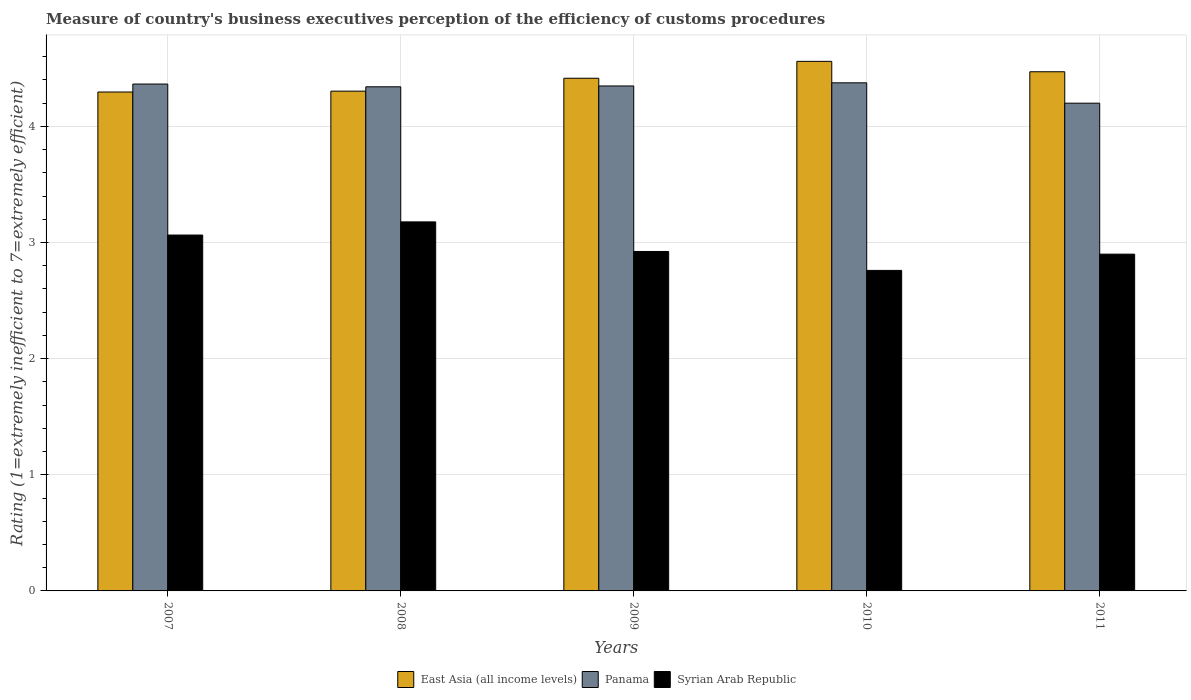Are the number of bars per tick equal to the number of legend labels?
Your answer should be compact. Yes. How many bars are there on the 3rd tick from the left?
Your answer should be very brief. 3. What is the label of the 1st group of bars from the left?
Offer a very short reply. 2007. What is the rating of the efficiency of customs procedure in Panama in 2007?
Your answer should be compact. 4.36. Across all years, what is the maximum rating of the efficiency of customs procedure in Panama?
Provide a short and direct response. 4.38. In which year was the rating of the efficiency of customs procedure in Panama maximum?
Provide a succinct answer. 2010. In which year was the rating of the efficiency of customs procedure in Panama minimum?
Offer a very short reply. 2011. What is the total rating of the efficiency of customs procedure in East Asia (all income levels) in the graph?
Ensure brevity in your answer.  22.05. What is the difference between the rating of the efficiency of customs procedure in Panama in 2007 and that in 2011?
Ensure brevity in your answer.  0.16. What is the difference between the rating of the efficiency of customs procedure in Syrian Arab Republic in 2008 and the rating of the efficiency of customs procedure in East Asia (all income levels) in 2010?
Make the answer very short. -1.38. What is the average rating of the efficiency of customs procedure in Panama per year?
Offer a terse response. 4.33. In the year 2007, what is the difference between the rating of the efficiency of customs procedure in Syrian Arab Republic and rating of the efficiency of customs procedure in Panama?
Keep it short and to the point. -1.3. What is the ratio of the rating of the efficiency of customs procedure in East Asia (all income levels) in 2009 to that in 2011?
Keep it short and to the point. 0.99. Is the difference between the rating of the efficiency of customs procedure in Syrian Arab Republic in 2009 and 2011 greater than the difference between the rating of the efficiency of customs procedure in Panama in 2009 and 2011?
Ensure brevity in your answer.  No. What is the difference between the highest and the second highest rating of the efficiency of customs procedure in Panama?
Make the answer very short. 0.01. What is the difference between the highest and the lowest rating of the efficiency of customs procedure in East Asia (all income levels)?
Provide a succinct answer. 0.26. What does the 2nd bar from the left in 2009 represents?
Keep it short and to the point. Panama. What does the 3rd bar from the right in 2010 represents?
Offer a very short reply. East Asia (all income levels). How many years are there in the graph?
Provide a succinct answer. 5. Are the values on the major ticks of Y-axis written in scientific E-notation?
Provide a succinct answer. No. Does the graph contain any zero values?
Ensure brevity in your answer.  No. What is the title of the graph?
Your answer should be very brief. Measure of country's business executives perception of the efficiency of customs procedures. What is the label or title of the Y-axis?
Keep it short and to the point. Rating (1=extremely inefficient to 7=extremely efficient). What is the Rating (1=extremely inefficient to 7=extremely efficient) in East Asia (all income levels) in 2007?
Your answer should be very brief. 4.3. What is the Rating (1=extremely inefficient to 7=extremely efficient) in Panama in 2007?
Provide a short and direct response. 4.36. What is the Rating (1=extremely inefficient to 7=extremely efficient) in Syrian Arab Republic in 2007?
Your answer should be very brief. 3.06. What is the Rating (1=extremely inefficient to 7=extremely efficient) in East Asia (all income levels) in 2008?
Your answer should be very brief. 4.3. What is the Rating (1=extremely inefficient to 7=extremely efficient) of Panama in 2008?
Your response must be concise. 4.34. What is the Rating (1=extremely inefficient to 7=extremely efficient) in Syrian Arab Republic in 2008?
Make the answer very short. 3.18. What is the Rating (1=extremely inefficient to 7=extremely efficient) of East Asia (all income levels) in 2009?
Offer a terse response. 4.41. What is the Rating (1=extremely inefficient to 7=extremely efficient) in Panama in 2009?
Provide a succinct answer. 4.35. What is the Rating (1=extremely inefficient to 7=extremely efficient) in Syrian Arab Republic in 2009?
Give a very brief answer. 2.92. What is the Rating (1=extremely inefficient to 7=extremely efficient) in East Asia (all income levels) in 2010?
Offer a terse response. 4.56. What is the Rating (1=extremely inefficient to 7=extremely efficient) in Panama in 2010?
Make the answer very short. 4.38. What is the Rating (1=extremely inefficient to 7=extremely efficient) of Syrian Arab Republic in 2010?
Make the answer very short. 2.76. What is the Rating (1=extremely inefficient to 7=extremely efficient) in East Asia (all income levels) in 2011?
Give a very brief answer. 4.47. What is the Rating (1=extremely inefficient to 7=extremely efficient) in Panama in 2011?
Provide a succinct answer. 4.2. What is the Rating (1=extremely inefficient to 7=extremely efficient) of Syrian Arab Republic in 2011?
Offer a very short reply. 2.9. Across all years, what is the maximum Rating (1=extremely inefficient to 7=extremely efficient) in East Asia (all income levels)?
Provide a succinct answer. 4.56. Across all years, what is the maximum Rating (1=extremely inefficient to 7=extremely efficient) in Panama?
Keep it short and to the point. 4.38. Across all years, what is the maximum Rating (1=extremely inefficient to 7=extremely efficient) in Syrian Arab Republic?
Offer a terse response. 3.18. Across all years, what is the minimum Rating (1=extremely inefficient to 7=extremely efficient) in East Asia (all income levels)?
Provide a short and direct response. 4.3. Across all years, what is the minimum Rating (1=extremely inefficient to 7=extremely efficient) of Syrian Arab Republic?
Keep it short and to the point. 2.76. What is the total Rating (1=extremely inefficient to 7=extremely efficient) in East Asia (all income levels) in the graph?
Provide a succinct answer. 22.05. What is the total Rating (1=extremely inefficient to 7=extremely efficient) in Panama in the graph?
Your answer should be very brief. 21.63. What is the total Rating (1=extremely inefficient to 7=extremely efficient) in Syrian Arab Republic in the graph?
Keep it short and to the point. 14.83. What is the difference between the Rating (1=extremely inefficient to 7=extremely efficient) of East Asia (all income levels) in 2007 and that in 2008?
Provide a short and direct response. -0.01. What is the difference between the Rating (1=extremely inefficient to 7=extremely efficient) in Panama in 2007 and that in 2008?
Make the answer very short. 0.02. What is the difference between the Rating (1=extremely inefficient to 7=extremely efficient) of Syrian Arab Republic in 2007 and that in 2008?
Offer a very short reply. -0.11. What is the difference between the Rating (1=extremely inefficient to 7=extremely efficient) of East Asia (all income levels) in 2007 and that in 2009?
Offer a terse response. -0.12. What is the difference between the Rating (1=extremely inefficient to 7=extremely efficient) in Panama in 2007 and that in 2009?
Make the answer very short. 0.02. What is the difference between the Rating (1=extremely inefficient to 7=extremely efficient) of Syrian Arab Republic in 2007 and that in 2009?
Make the answer very short. 0.14. What is the difference between the Rating (1=extremely inefficient to 7=extremely efficient) of East Asia (all income levels) in 2007 and that in 2010?
Provide a succinct answer. -0.26. What is the difference between the Rating (1=extremely inefficient to 7=extremely efficient) in Panama in 2007 and that in 2010?
Your answer should be compact. -0.01. What is the difference between the Rating (1=extremely inefficient to 7=extremely efficient) of Syrian Arab Republic in 2007 and that in 2010?
Your answer should be compact. 0.3. What is the difference between the Rating (1=extremely inefficient to 7=extremely efficient) of East Asia (all income levels) in 2007 and that in 2011?
Your answer should be compact. -0.17. What is the difference between the Rating (1=extremely inefficient to 7=extremely efficient) in Panama in 2007 and that in 2011?
Keep it short and to the point. 0.16. What is the difference between the Rating (1=extremely inefficient to 7=extremely efficient) of Syrian Arab Republic in 2007 and that in 2011?
Ensure brevity in your answer.  0.16. What is the difference between the Rating (1=extremely inefficient to 7=extremely efficient) of East Asia (all income levels) in 2008 and that in 2009?
Provide a succinct answer. -0.11. What is the difference between the Rating (1=extremely inefficient to 7=extremely efficient) in Panama in 2008 and that in 2009?
Keep it short and to the point. -0.01. What is the difference between the Rating (1=extremely inefficient to 7=extremely efficient) of Syrian Arab Republic in 2008 and that in 2009?
Offer a terse response. 0.25. What is the difference between the Rating (1=extremely inefficient to 7=extremely efficient) of East Asia (all income levels) in 2008 and that in 2010?
Offer a very short reply. -0.26. What is the difference between the Rating (1=extremely inefficient to 7=extremely efficient) in Panama in 2008 and that in 2010?
Keep it short and to the point. -0.03. What is the difference between the Rating (1=extremely inefficient to 7=extremely efficient) of Syrian Arab Republic in 2008 and that in 2010?
Your response must be concise. 0.42. What is the difference between the Rating (1=extremely inefficient to 7=extremely efficient) of East Asia (all income levels) in 2008 and that in 2011?
Provide a short and direct response. -0.17. What is the difference between the Rating (1=extremely inefficient to 7=extremely efficient) in Panama in 2008 and that in 2011?
Keep it short and to the point. 0.14. What is the difference between the Rating (1=extremely inefficient to 7=extremely efficient) in Syrian Arab Republic in 2008 and that in 2011?
Offer a very short reply. 0.28. What is the difference between the Rating (1=extremely inefficient to 7=extremely efficient) in East Asia (all income levels) in 2009 and that in 2010?
Keep it short and to the point. -0.15. What is the difference between the Rating (1=extremely inefficient to 7=extremely efficient) in Panama in 2009 and that in 2010?
Ensure brevity in your answer.  -0.03. What is the difference between the Rating (1=extremely inefficient to 7=extremely efficient) of Syrian Arab Republic in 2009 and that in 2010?
Offer a terse response. 0.16. What is the difference between the Rating (1=extremely inefficient to 7=extremely efficient) of East Asia (all income levels) in 2009 and that in 2011?
Make the answer very short. -0.06. What is the difference between the Rating (1=extremely inefficient to 7=extremely efficient) of Panama in 2009 and that in 2011?
Your response must be concise. 0.15. What is the difference between the Rating (1=extremely inefficient to 7=extremely efficient) in Syrian Arab Republic in 2009 and that in 2011?
Keep it short and to the point. 0.02. What is the difference between the Rating (1=extremely inefficient to 7=extremely efficient) of East Asia (all income levels) in 2010 and that in 2011?
Offer a terse response. 0.09. What is the difference between the Rating (1=extremely inefficient to 7=extremely efficient) in Panama in 2010 and that in 2011?
Offer a very short reply. 0.18. What is the difference between the Rating (1=extremely inefficient to 7=extremely efficient) of Syrian Arab Republic in 2010 and that in 2011?
Keep it short and to the point. -0.14. What is the difference between the Rating (1=extremely inefficient to 7=extremely efficient) of East Asia (all income levels) in 2007 and the Rating (1=extremely inefficient to 7=extremely efficient) of Panama in 2008?
Offer a terse response. -0.04. What is the difference between the Rating (1=extremely inefficient to 7=extremely efficient) of East Asia (all income levels) in 2007 and the Rating (1=extremely inefficient to 7=extremely efficient) of Syrian Arab Republic in 2008?
Keep it short and to the point. 1.12. What is the difference between the Rating (1=extremely inefficient to 7=extremely efficient) of Panama in 2007 and the Rating (1=extremely inefficient to 7=extremely efficient) of Syrian Arab Republic in 2008?
Your answer should be compact. 1.19. What is the difference between the Rating (1=extremely inefficient to 7=extremely efficient) of East Asia (all income levels) in 2007 and the Rating (1=extremely inefficient to 7=extremely efficient) of Panama in 2009?
Keep it short and to the point. -0.05. What is the difference between the Rating (1=extremely inefficient to 7=extremely efficient) in East Asia (all income levels) in 2007 and the Rating (1=extremely inefficient to 7=extremely efficient) in Syrian Arab Republic in 2009?
Provide a succinct answer. 1.37. What is the difference between the Rating (1=extremely inefficient to 7=extremely efficient) of Panama in 2007 and the Rating (1=extremely inefficient to 7=extremely efficient) of Syrian Arab Republic in 2009?
Give a very brief answer. 1.44. What is the difference between the Rating (1=extremely inefficient to 7=extremely efficient) of East Asia (all income levels) in 2007 and the Rating (1=extremely inefficient to 7=extremely efficient) of Panama in 2010?
Provide a succinct answer. -0.08. What is the difference between the Rating (1=extremely inefficient to 7=extremely efficient) of East Asia (all income levels) in 2007 and the Rating (1=extremely inefficient to 7=extremely efficient) of Syrian Arab Republic in 2010?
Ensure brevity in your answer.  1.54. What is the difference between the Rating (1=extremely inefficient to 7=extremely efficient) in Panama in 2007 and the Rating (1=extremely inefficient to 7=extremely efficient) in Syrian Arab Republic in 2010?
Your answer should be compact. 1.6. What is the difference between the Rating (1=extremely inefficient to 7=extremely efficient) in East Asia (all income levels) in 2007 and the Rating (1=extremely inefficient to 7=extremely efficient) in Panama in 2011?
Offer a terse response. 0.1. What is the difference between the Rating (1=extremely inefficient to 7=extremely efficient) of East Asia (all income levels) in 2007 and the Rating (1=extremely inefficient to 7=extremely efficient) of Syrian Arab Republic in 2011?
Provide a short and direct response. 1.4. What is the difference between the Rating (1=extremely inefficient to 7=extremely efficient) of Panama in 2007 and the Rating (1=extremely inefficient to 7=extremely efficient) of Syrian Arab Republic in 2011?
Provide a succinct answer. 1.46. What is the difference between the Rating (1=extremely inefficient to 7=extremely efficient) in East Asia (all income levels) in 2008 and the Rating (1=extremely inefficient to 7=extremely efficient) in Panama in 2009?
Make the answer very short. -0.04. What is the difference between the Rating (1=extremely inefficient to 7=extremely efficient) of East Asia (all income levels) in 2008 and the Rating (1=extremely inefficient to 7=extremely efficient) of Syrian Arab Republic in 2009?
Offer a very short reply. 1.38. What is the difference between the Rating (1=extremely inefficient to 7=extremely efficient) of Panama in 2008 and the Rating (1=extremely inefficient to 7=extremely efficient) of Syrian Arab Republic in 2009?
Your response must be concise. 1.42. What is the difference between the Rating (1=extremely inefficient to 7=extremely efficient) in East Asia (all income levels) in 2008 and the Rating (1=extremely inefficient to 7=extremely efficient) in Panama in 2010?
Ensure brevity in your answer.  -0.07. What is the difference between the Rating (1=extremely inefficient to 7=extremely efficient) in East Asia (all income levels) in 2008 and the Rating (1=extremely inefficient to 7=extremely efficient) in Syrian Arab Republic in 2010?
Provide a succinct answer. 1.54. What is the difference between the Rating (1=extremely inefficient to 7=extremely efficient) of Panama in 2008 and the Rating (1=extremely inefficient to 7=extremely efficient) of Syrian Arab Republic in 2010?
Your answer should be compact. 1.58. What is the difference between the Rating (1=extremely inefficient to 7=extremely efficient) of East Asia (all income levels) in 2008 and the Rating (1=extremely inefficient to 7=extremely efficient) of Panama in 2011?
Ensure brevity in your answer.  0.1. What is the difference between the Rating (1=extremely inefficient to 7=extremely efficient) in East Asia (all income levels) in 2008 and the Rating (1=extremely inefficient to 7=extremely efficient) in Syrian Arab Republic in 2011?
Provide a short and direct response. 1.4. What is the difference between the Rating (1=extremely inefficient to 7=extremely efficient) in Panama in 2008 and the Rating (1=extremely inefficient to 7=extremely efficient) in Syrian Arab Republic in 2011?
Offer a terse response. 1.44. What is the difference between the Rating (1=extremely inefficient to 7=extremely efficient) in East Asia (all income levels) in 2009 and the Rating (1=extremely inefficient to 7=extremely efficient) in Panama in 2010?
Offer a very short reply. 0.04. What is the difference between the Rating (1=extremely inefficient to 7=extremely efficient) of East Asia (all income levels) in 2009 and the Rating (1=extremely inefficient to 7=extremely efficient) of Syrian Arab Republic in 2010?
Your answer should be very brief. 1.65. What is the difference between the Rating (1=extremely inefficient to 7=extremely efficient) of Panama in 2009 and the Rating (1=extremely inefficient to 7=extremely efficient) of Syrian Arab Republic in 2010?
Offer a very short reply. 1.59. What is the difference between the Rating (1=extremely inefficient to 7=extremely efficient) in East Asia (all income levels) in 2009 and the Rating (1=extremely inefficient to 7=extremely efficient) in Panama in 2011?
Offer a very short reply. 0.21. What is the difference between the Rating (1=extremely inefficient to 7=extremely efficient) in East Asia (all income levels) in 2009 and the Rating (1=extremely inefficient to 7=extremely efficient) in Syrian Arab Republic in 2011?
Your response must be concise. 1.51. What is the difference between the Rating (1=extremely inefficient to 7=extremely efficient) of Panama in 2009 and the Rating (1=extremely inefficient to 7=extremely efficient) of Syrian Arab Republic in 2011?
Keep it short and to the point. 1.45. What is the difference between the Rating (1=extremely inefficient to 7=extremely efficient) of East Asia (all income levels) in 2010 and the Rating (1=extremely inefficient to 7=extremely efficient) of Panama in 2011?
Your response must be concise. 0.36. What is the difference between the Rating (1=extremely inefficient to 7=extremely efficient) in East Asia (all income levels) in 2010 and the Rating (1=extremely inefficient to 7=extremely efficient) in Syrian Arab Republic in 2011?
Your response must be concise. 1.66. What is the difference between the Rating (1=extremely inefficient to 7=extremely efficient) of Panama in 2010 and the Rating (1=extremely inefficient to 7=extremely efficient) of Syrian Arab Republic in 2011?
Keep it short and to the point. 1.48. What is the average Rating (1=extremely inefficient to 7=extremely efficient) in East Asia (all income levels) per year?
Provide a succinct answer. 4.41. What is the average Rating (1=extremely inefficient to 7=extremely efficient) in Panama per year?
Offer a terse response. 4.33. What is the average Rating (1=extremely inefficient to 7=extremely efficient) in Syrian Arab Republic per year?
Offer a terse response. 2.97. In the year 2007, what is the difference between the Rating (1=extremely inefficient to 7=extremely efficient) in East Asia (all income levels) and Rating (1=extremely inefficient to 7=extremely efficient) in Panama?
Your answer should be very brief. -0.07. In the year 2007, what is the difference between the Rating (1=extremely inefficient to 7=extremely efficient) of East Asia (all income levels) and Rating (1=extremely inefficient to 7=extremely efficient) of Syrian Arab Republic?
Ensure brevity in your answer.  1.23. In the year 2007, what is the difference between the Rating (1=extremely inefficient to 7=extremely efficient) in Panama and Rating (1=extremely inefficient to 7=extremely efficient) in Syrian Arab Republic?
Make the answer very short. 1.3. In the year 2008, what is the difference between the Rating (1=extremely inefficient to 7=extremely efficient) in East Asia (all income levels) and Rating (1=extremely inefficient to 7=extremely efficient) in Panama?
Ensure brevity in your answer.  -0.04. In the year 2008, what is the difference between the Rating (1=extremely inefficient to 7=extremely efficient) of East Asia (all income levels) and Rating (1=extremely inefficient to 7=extremely efficient) of Syrian Arab Republic?
Provide a short and direct response. 1.13. In the year 2008, what is the difference between the Rating (1=extremely inefficient to 7=extremely efficient) of Panama and Rating (1=extremely inefficient to 7=extremely efficient) of Syrian Arab Republic?
Offer a terse response. 1.16. In the year 2009, what is the difference between the Rating (1=extremely inefficient to 7=extremely efficient) in East Asia (all income levels) and Rating (1=extremely inefficient to 7=extremely efficient) in Panama?
Your answer should be compact. 0.07. In the year 2009, what is the difference between the Rating (1=extremely inefficient to 7=extremely efficient) in East Asia (all income levels) and Rating (1=extremely inefficient to 7=extremely efficient) in Syrian Arab Republic?
Provide a short and direct response. 1.49. In the year 2009, what is the difference between the Rating (1=extremely inefficient to 7=extremely efficient) of Panama and Rating (1=extremely inefficient to 7=extremely efficient) of Syrian Arab Republic?
Make the answer very short. 1.43. In the year 2010, what is the difference between the Rating (1=extremely inefficient to 7=extremely efficient) in East Asia (all income levels) and Rating (1=extremely inefficient to 7=extremely efficient) in Panama?
Your answer should be very brief. 0.18. In the year 2010, what is the difference between the Rating (1=extremely inefficient to 7=extremely efficient) in East Asia (all income levels) and Rating (1=extremely inefficient to 7=extremely efficient) in Syrian Arab Republic?
Provide a short and direct response. 1.8. In the year 2010, what is the difference between the Rating (1=extremely inefficient to 7=extremely efficient) in Panama and Rating (1=extremely inefficient to 7=extremely efficient) in Syrian Arab Republic?
Keep it short and to the point. 1.62. In the year 2011, what is the difference between the Rating (1=extremely inefficient to 7=extremely efficient) in East Asia (all income levels) and Rating (1=extremely inefficient to 7=extremely efficient) in Panama?
Your response must be concise. 0.27. In the year 2011, what is the difference between the Rating (1=extremely inefficient to 7=extremely efficient) in East Asia (all income levels) and Rating (1=extremely inefficient to 7=extremely efficient) in Syrian Arab Republic?
Your answer should be very brief. 1.57. In the year 2011, what is the difference between the Rating (1=extremely inefficient to 7=extremely efficient) in Panama and Rating (1=extremely inefficient to 7=extremely efficient) in Syrian Arab Republic?
Ensure brevity in your answer.  1.3. What is the ratio of the Rating (1=extremely inefficient to 7=extremely efficient) in East Asia (all income levels) in 2007 to that in 2008?
Ensure brevity in your answer.  1. What is the ratio of the Rating (1=extremely inefficient to 7=extremely efficient) in Panama in 2007 to that in 2008?
Make the answer very short. 1.01. What is the ratio of the Rating (1=extremely inefficient to 7=extremely efficient) in Syrian Arab Republic in 2007 to that in 2008?
Your answer should be very brief. 0.96. What is the ratio of the Rating (1=extremely inefficient to 7=extremely efficient) in East Asia (all income levels) in 2007 to that in 2009?
Ensure brevity in your answer.  0.97. What is the ratio of the Rating (1=extremely inefficient to 7=extremely efficient) in Syrian Arab Republic in 2007 to that in 2009?
Your answer should be compact. 1.05. What is the ratio of the Rating (1=extremely inefficient to 7=extremely efficient) of East Asia (all income levels) in 2007 to that in 2010?
Offer a very short reply. 0.94. What is the ratio of the Rating (1=extremely inefficient to 7=extremely efficient) of Panama in 2007 to that in 2010?
Your answer should be very brief. 1. What is the ratio of the Rating (1=extremely inefficient to 7=extremely efficient) in Syrian Arab Republic in 2007 to that in 2010?
Your response must be concise. 1.11. What is the ratio of the Rating (1=extremely inefficient to 7=extremely efficient) in Panama in 2007 to that in 2011?
Provide a succinct answer. 1.04. What is the ratio of the Rating (1=extremely inefficient to 7=extremely efficient) of Syrian Arab Republic in 2007 to that in 2011?
Your answer should be compact. 1.06. What is the ratio of the Rating (1=extremely inefficient to 7=extremely efficient) of East Asia (all income levels) in 2008 to that in 2009?
Give a very brief answer. 0.97. What is the ratio of the Rating (1=extremely inefficient to 7=extremely efficient) in Syrian Arab Republic in 2008 to that in 2009?
Offer a very short reply. 1.09. What is the ratio of the Rating (1=extremely inefficient to 7=extremely efficient) in East Asia (all income levels) in 2008 to that in 2010?
Keep it short and to the point. 0.94. What is the ratio of the Rating (1=extremely inefficient to 7=extremely efficient) in Panama in 2008 to that in 2010?
Your response must be concise. 0.99. What is the ratio of the Rating (1=extremely inefficient to 7=extremely efficient) in Syrian Arab Republic in 2008 to that in 2010?
Your answer should be very brief. 1.15. What is the ratio of the Rating (1=extremely inefficient to 7=extremely efficient) in East Asia (all income levels) in 2008 to that in 2011?
Provide a short and direct response. 0.96. What is the ratio of the Rating (1=extremely inefficient to 7=extremely efficient) in Panama in 2008 to that in 2011?
Make the answer very short. 1.03. What is the ratio of the Rating (1=extremely inefficient to 7=extremely efficient) in Syrian Arab Republic in 2008 to that in 2011?
Provide a short and direct response. 1.1. What is the ratio of the Rating (1=extremely inefficient to 7=extremely efficient) in East Asia (all income levels) in 2009 to that in 2010?
Offer a terse response. 0.97. What is the ratio of the Rating (1=extremely inefficient to 7=extremely efficient) in Syrian Arab Republic in 2009 to that in 2010?
Your answer should be very brief. 1.06. What is the ratio of the Rating (1=extremely inefficient to 7=extremely efficient) in East Asia (all income levels) in 2009 to that in 2011?
Offer a terse response. 0.99. What is the ratio of the Rating (1=extremely inefficient to 7=extremely efficient) in Panama in 2009 to that in 2011?
Your answer should be very brief. 1.04. What is the ratio of the Rating (1=extremely inefficient to 7=extremely efficient) of Syrian Arab Republic in 2009 to that in 2011?
Your response must be concise. 1.01. What is the ratio of the Rating (1=extremely inefficient to 7=extremely efficient) in Panama in 2010 to that in 2011?
Provide a short and direct response. 1.04. What is the ratio of the Rating (1=extremely inefficient to 7=extremely efficient) in Syrian Arab Republic in 2010 to that in 2011?
Give a very brief answer. 0.95. What is the difference between the highest and the second highest Rating (1=extremely inefficient to 7=extremely efficient) of East Asia (all income levels)?
Offer a terse response. 0.09. What is the difference between the highest and the second highest Rating (1=extremely inefficient to 7=extremely efficient) in Panama?
Make the answer very short. 0.01. What is the difference between the highest and the second highest Rating (1=extremely inefficient to 7=extremely efficient) of Syrian Arab Republic?
Give a very brief answer. 0.11. What is the difference between the highest and the lowest Rating (1=extremely inefficient to 7=extremely efficient) in East Asia (all income levels)?
Give a very brief answer. 0.26. What is the difference between the highest and the lowest Rating (1=extremely inefficient to 7=extremely efficient) in Panama?
Your answer should be compact. 0.18. What is the difference between the highest and the lowest Rating (1=extremely inefficient to 7=extremely efficient) in Syrian Arab Republic?
Offer a very short reply. 0.42. 